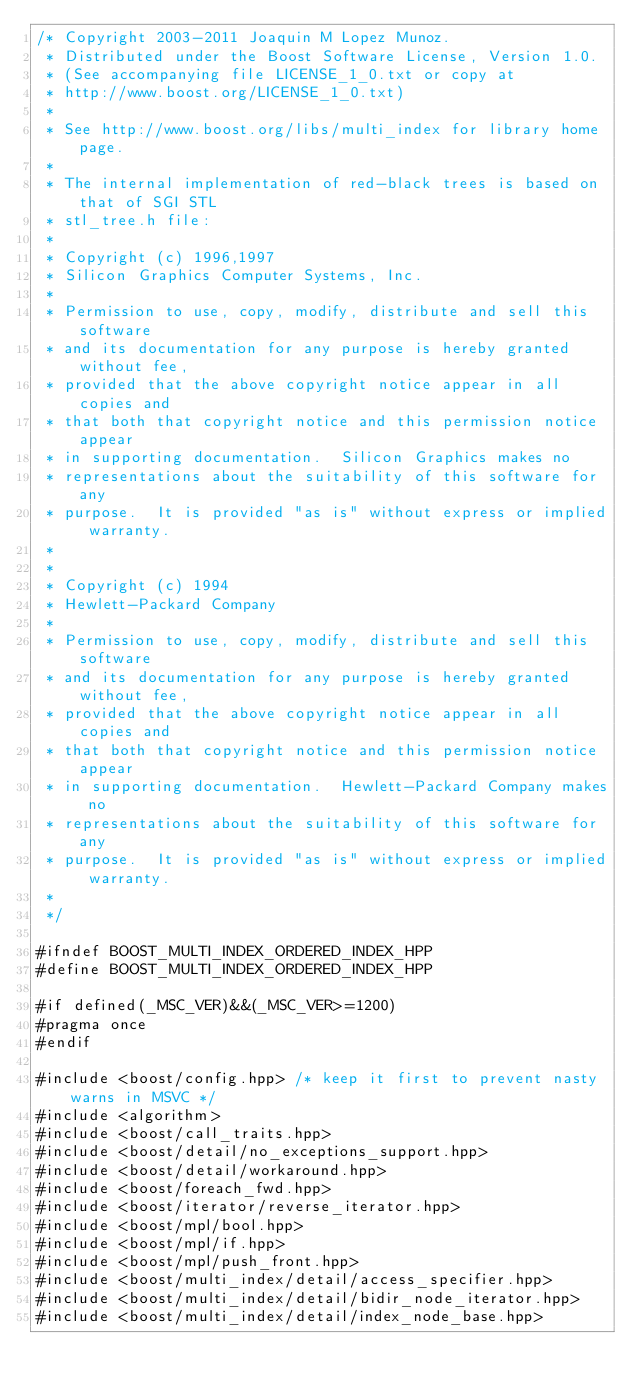Convert code to text. <code><loc_0><loc_0><loc_500><loc_500><_C++_>/* Copyright 2003-2011 Joaquin M Lopez Munoz.
 * Distributed under the Boost Software License, Version 1.0.
 * (See accompanying file LICENSE_1_0.txt or copy at
 * http://www.boost.org/LICENSE_1_0.txt)
 *
 * See http://www.boost.org/libs/multi_index for library home page.
 *
 * The internal implementation of red-black trees is based on that of SGI STL
 * stl_tree.h file: 
 *
 * Copyright (c) 1996,1997
 * Silicon Graphics Computer Systems, Inc.
 *
 * Permission to use, copy, modify, distribute and sell this software
 * and its documentation for any purpose is hereby granted without fee,
 * provided that the above copyright notice appear in all copies and
 * that both that copyright notice and this permission notice appear
 * in supporting documentation.  Silicon Graphics makes no
 * representations about the suitability of this software for any
 * purpose.  It is provided "as is" without express or implied warranty.
 *
 *
 * Copyright (c) 1994
 * Hewlett-Packard Company
 *
 * Permission to use, copy, modify, distribute and sell this software
 * and its documentation for any purpose is hereby granted without fee,
 * provided that the above copyright notice appear in all copies and
 * that both that copyright notice and this permission notice appear
 * in supporting documentation.  Hewlett-Packard Company makes no
 * representations about the suitability of this software for any
 * purpose.  It is provided "as is" without express or implied warranty.
 *
 */

#ifndef BOOST_MULTI_INDEX_ORDERED_INDEX_HPP
#define BOOST_MULTI_INDEX_ORDERED_INDEX_HPP

#if defined(_MSC_VER)&&(_MSC_VER>=1200)
#pragma once
#endif

#include <boost/config.hpp> /* keep it first to prevent nasty warns in MSVC */
#include <algorithm>
#include <boost/call_traits.hpp>
#include <boost/detail/no_exceptions_support.hpp>
#include <boost/detail/workaround.hpp>
#include <boost/foreach_fwd.hpp>
#include <boost/iterator/reverse_iterator.hpp>
#include <boost/mpl/bool.hpp>
#include <boost/mpl/if.hpp>
#include <boost/mpl/push_front.hpp>
#include <boost/multi_index/detail/access_specifier.hpp>
#include <boost/multi_index/detail/bidir_node_iterator.hpp>
#include <boost/multi_index/detail/index_node_base.hpp></code> 